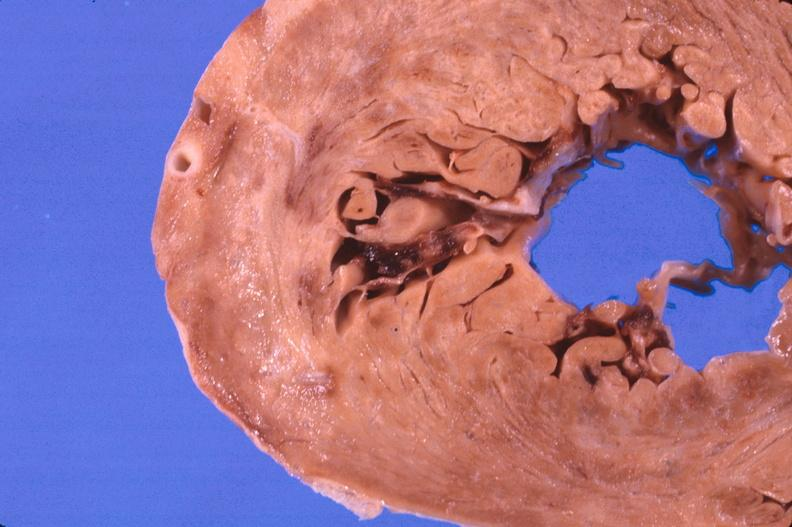what does this image show?
Answer the question using a single word or phrase. Heart 